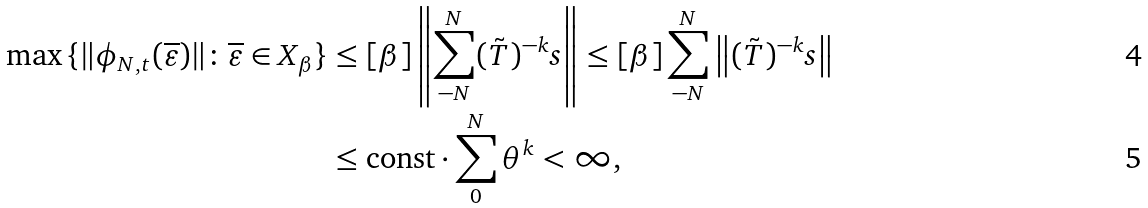<formula> <loc_0><loc_0><loc_500><loc_500>\max \, \{ \| \phi _ { N , t } ( \overline { \varepsilon } ) \| \colon \overline { \varepsilon } \in X _ { \beta } \} & \leq [ \beta ] \left \| \sum _ { - N } ^ { N } ( \tilde { T } ) ^ { - k } s \right \| \leq [ \beta ] \sum _ { - N } ^ { N } \left \| ( \tilde { T } ) ^ { - k } s \right \| \\ & \leq \text {const} \cdot \sum _ { 0 } ^ { N } \theta ^ { k } < \infty ,</formula> 